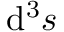Convert formula to latex. <formula><loc_0><loc_0><loc_500><loc_500>d ^ { 3 } { s }</formula> 